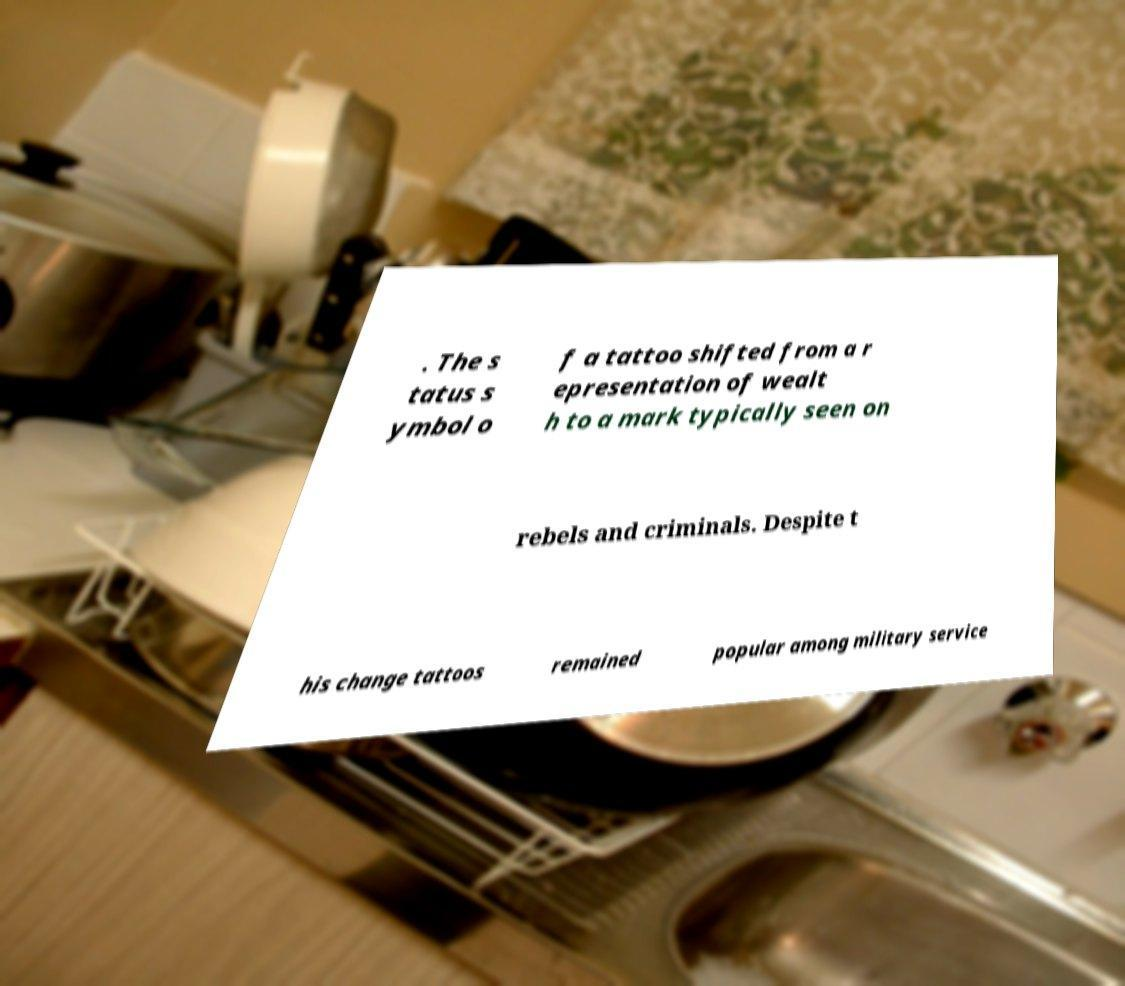What messages or text are displayed in this image? I need them in a readable, typed format. . The s tatus s ymbol o f a tattoo shifted from a r epresentation of wealt h to a mark typically seen on rebels and criminals. Despite t his change tattoos remained popular among military service 